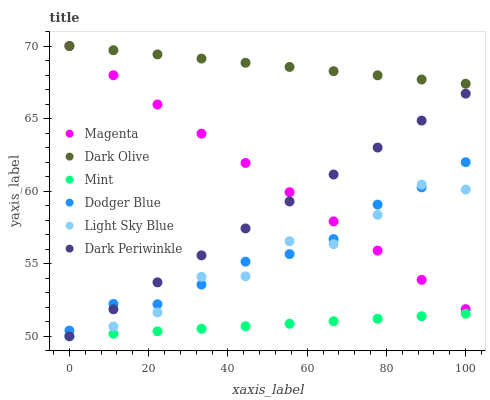Does Mint have the minimum area under the curve?
Answer yes or no. Yes. Does Dark Olive have the maximum area under the curve?
Answer yes or no. Yes. Does Light Sky Blue have the minimum area under the curve?
Answer yes or no. No. Does Light Sky Blue have the maximum area under the curve?
Answer yes or no. No. Is Magenta the smoothest?
Answer yes or no. Yes. Is Light Sky Blue the roughest?
Answer yes or no. Yes. Is Dodger Blue the smoothest?
Answer yes or no. No. Is Dodger Blue the roughest?
Answer yes or no. No. Does Light Sky Blue have the lowest value?
Answer yes or no. Yes. Does Dodger Blue have the lowest value?
Answer yes or no. No. Does Magenta have the highest value?
Answer yes or no. Yes. Does Light Sky Blue have the highest value?
Answer yes or no. No. Is Mint less than Magenta?
Answer yes or no. Yes. Is Dark Olive greater than Light Sky Blue?
Answer yes or no. Yes. Does Dark Olive intersect Magenta?
Answer yes or no. Yes. Is Dark Olive less than Magenta?
Answer yes or no. No. Is Dark Olive greater than Magenta?
Answer yes or no. No. Does Mint intersect Magenta?
Answer yes or no. No. 